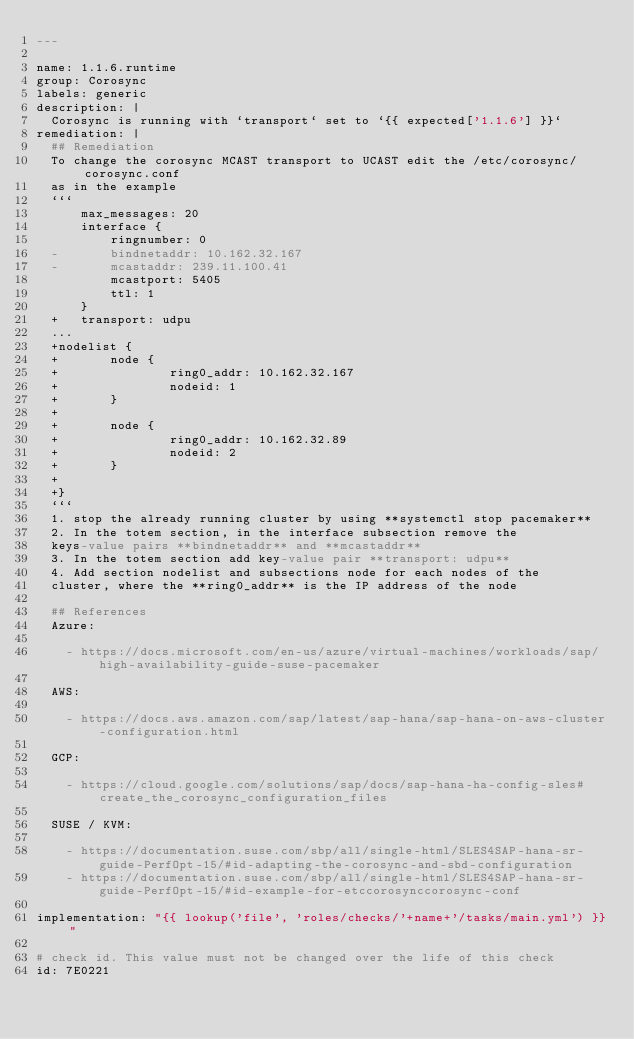<code> <loc_0><loc_0><loc_500><loc_500><_YAML_>---

name: 1.1.6.runtime
group: Corosync
labels: generic
description: |
  Corosync is running with `transport` set to `{{ expected['1.1.6'] }}`
remediation: |
  ## Remediation
  To change the corosync MCAST transport to UCAST edit the /etc/corosync/corosync.conf
  as in the example
  ```
      max_messages: 20
      interface {
          ringnumber: 0
  -       bindnetaddr: 10.162.32.167
  -       mcastaddr: 239.11.100.41
          mcastport: 5405
          ttl: 1
      }
  +   transport: udpu
  ...
  +nodelist {
  +       node {
  +               ring0_addr: 10.162.32.167
  +               nodeid: 1
  +       }
  +
  +       node {
  +               ring0_addr: 10.162.32.89
  +               nodeid: 2
  +       }
  +
  +}
  ```
  1. stop the already running cluster by using **systemctl stop pacemaker**
  2. In the totem section, in the interface subsection remove the
  keys-value pairs **bindnetaddr** and **mcastaddr**
  3. In the totem section add key-value pair **transport: udpu**
  4. Add section nodelist and subsections node for each nodes of the
  cluster, where the **ring0_addr** is the IP address of the node

  ## References
  Azure:

    - https://docs.microsoft.com/en-us/azure/virtual-machines/workloads/sap/high-availability-guide-suse-pacemaker

  AWS:

    - https://docs.aws.amazon.com/sap/latest/sap-hana/sap-hana-on-aws-cluster-configuration.html

  GCP:

    - https://cloud.google.com/solutions/sap/docs/sap-hana-ha-config-sles#create_the_corosync_configuration_files

  SUSE / KVM:

    - https://documentation.suse.com/sbp/all/single-html/SLES4SAP-hana-sr-guide-PerfOpt-15/#id-adapting-the-corosync-and-sbd-configuration
    - https://documentation.suse.com/sbp/all/single-html/SLES4SAP-hana-sr-guide-PerfOpt-15/#id-example-for-etccorosynccorosync-conf

implementation: "{{ lookup('file', 'roles/checks/'+name+'/tasks/main.yml') }}"

# check id. This value must not be changed over the life of this check
id: 7E0221
</code> 